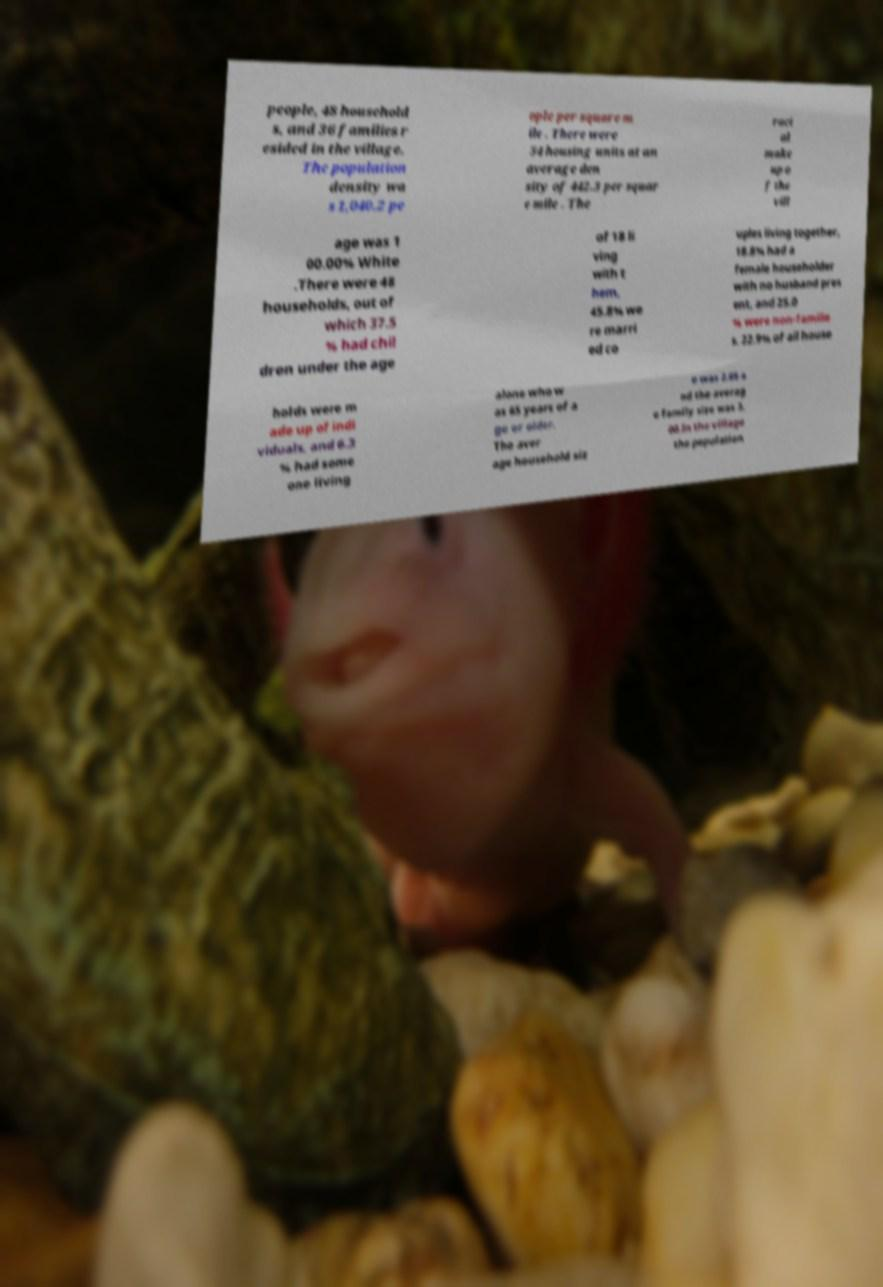Could you assist in decoding the text presented in this image and type it out clearly? people, 48 household s, and 36 families r esided in the village. The population density wa s 1,040.2 pe ople per square m ile . There were 54 housing units at an average den sity of 442.3 per squar e mile . The raci al make up o f the vill age was 1 00.00% White .There were 48 households, out of which 37.5 % had chil dren under the age of 18 li ving with t hem, 45.8% we re marri ed co uples living together, 18.8% had a female householder with no husband pres ent, and 25.0 % were non-familie s. 22.9% of all house holds were m ade up of indi viduals, and 6.3 % had some one living alone who w as 65 years of a ge or older. The aver age household siz e was 2.65 a nd the averag e family size was 3. 00.In the village the population 